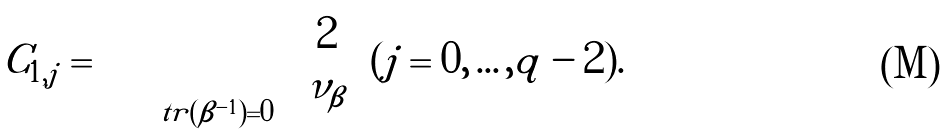Convert formula to latex. <formula><loc_0><loc_0><loc_500><loc_500>C _ { 1 , j } = \sum \prod _ { t r ( \beta ^ { - 1 } ) = 0 } { 2 \choose \nu _ { \beta } } ( j = 0 , \dots , q - 2 ) .</formula> 